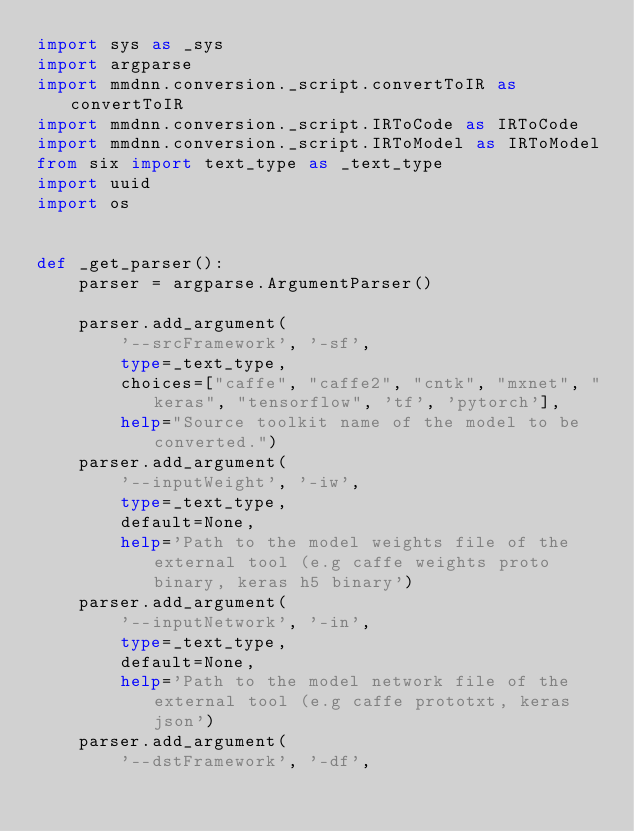<code> <loc_0><loc_0><loc_500><loc_500><_Python_>import sys as _sys
import argparse
import mmdnn.conversion._script.convertToIR as convertToIR
import mmdnn.conversion._script.IRToCode as IRToCode
import mmdnn.conversion._script.IRToModel as IRToModel
from six import text_type as _text_type
import uuid
import os


def _get_parser():
    parser = argparse.ArgumentParser()

    parser.add_argument(
        '--srcFramework', '-sf',
        type=_text_type,
        choices=["caffe", "caffe2", "cntk", "mxnet", "keras", "tensorflow", 'tf', 'pytorch'],
        help="Source toolkit name of the model to be converted.")
    parser.add_argument(
        '--inputWeight', '-iw',
        type=_text_type,
        default=None,
        help='Path to the model weights file of the external tool (e.g caffe weights proto binary, keras h5 binary')
    parser.add_argument(
        '--inputNetwork', '-in',
        type=_text_type,
        default=None,
        help='Path to the model network file of the external tool (e.g caffe prototxt, keras json')
    parser.add_argument(
        '--dstFramework', '-df',</code> 